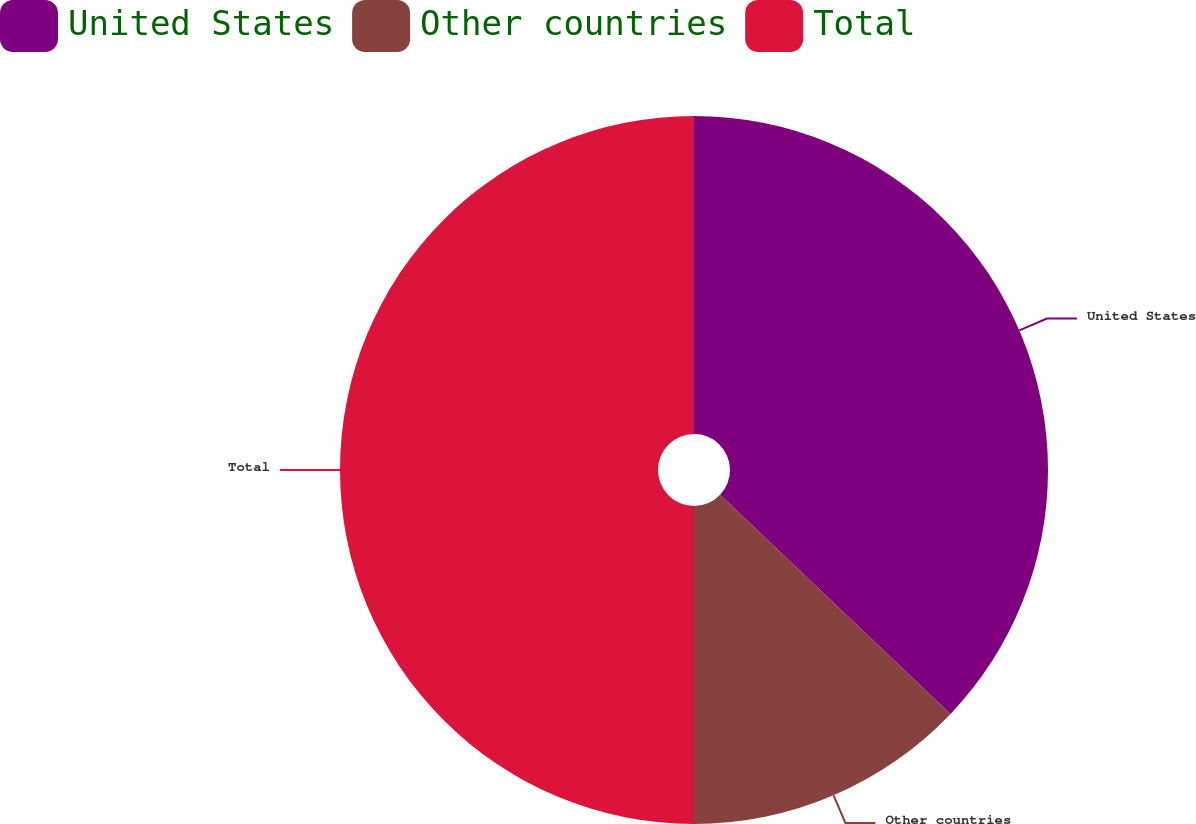Convert chart. <chart><loc_0><loc_0><loc_500><loc_500><pie_chart><fcel>United States<fcel>Other countries<fcel>Total<nl><fcel>37.1%<fcel>12.9%<fcel>50.0%<nl></chart> 